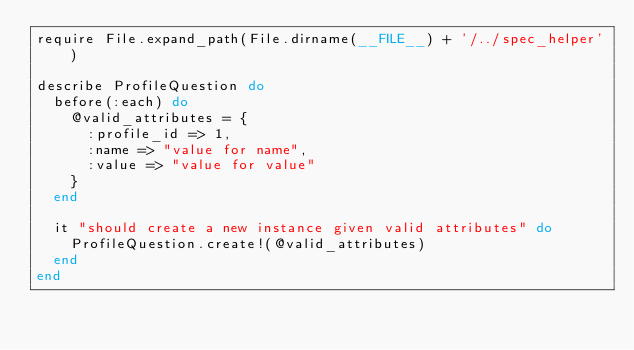Convert code to text. <code><loc_0><loc_0><loc_500><loc_500><_Ruby_>require File.expand_path(File.dirname(__FILE__) + '/../spec_helper')

describe ProfileQuestion do
  before(:each) do
    @valid_attributes = {
      :profile_id => 1,
      :name => "value for name",
      :value => "value for value"
    }
  end

  it "should create a new instance given valid attributes" do
    ProfileQuestion.create!(@valid_attributes)
  end
end
</code> 